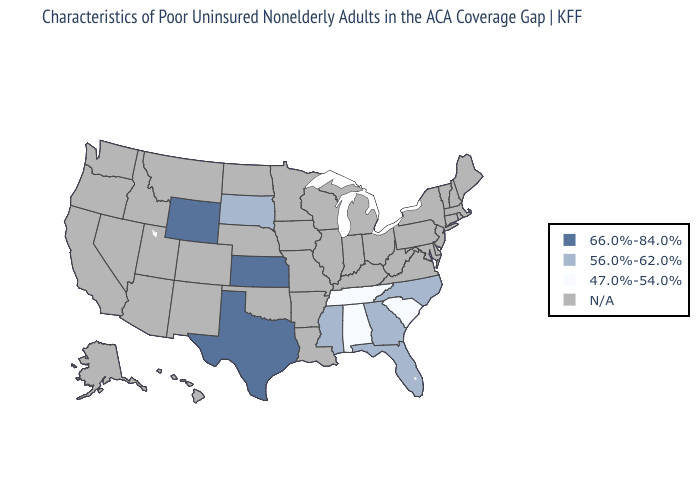What is the value of Illinois?
Give a very brief answer. N/A. Name the states that have a value in the range N/A?
Be succinct. Alaska, Arizona, Arkansas, California, Colorado, Connecticut, Delaware, Hawaii, Idaho, Illinois, Indiana, Iowa, Kentucky, Louisiana, Maine, Maryland, Massachusetts, Michigan, Minnesota, Missouri, Montana, Nebraska, Nevada, New Hampshire, New Jersey, New Mexico, New York, North Dakota, Ohio, Oklahoma, Oregon, Pennsylvania, Rhode Island, Utah, Vermont, Virginia, Washington, West Virginia, Wisconsin. What is the lowest value in the USA?
Short answer required. 47.0%-54.0%. What is the value of Tennessee?
Concise answer only. 47.0%-54.0%. Does Alabama have the lowest value in the USA?
Give a very brief answer. Yes. Does South Dakota have the highest value in the USA?
Answer briefly. No. Does Mississippi have the highest value in the South?
Give a very brief answer. No. Among the states that border South Dakota , which have the lowest value?
Quick response, please. Wyoming. Name the states that have a value in the range 47.0%-54.0%?
Write a very short answer. Alabama, South Carolina, Tennessee. 